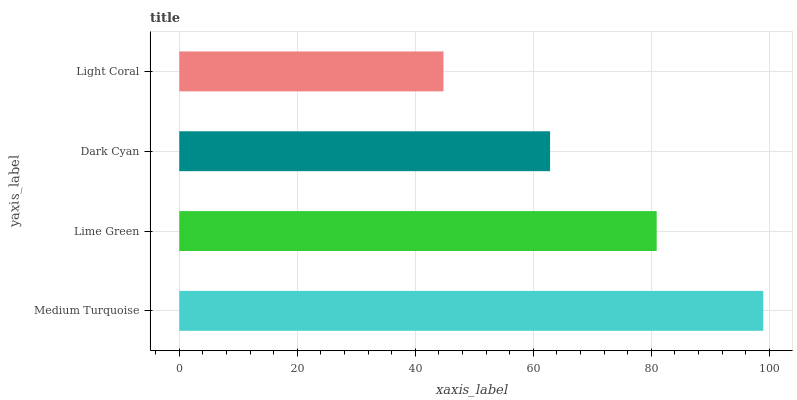Is Light Coral the minimum?
Answer yes or no. Yes. Is Medium Turquoise the maximum?
Answer yes or no. Yes. Is Lime Green the minimum?
Answer yes or no. No. Is Lime Green the maximum?
Answer yes or no. No. Is Medium Turquoise greater than Lime Green?
Answer yes or no. Yes. Is Lime Green less than Medium Turquoise?
Answer yes or no. Yes. Is Lime Green greater than Medium Turquoise?
Answer yes or no. No. Is Medium Turquoise less than Lime Green?
Answer yes or no. No. Is Lime Green the high median?
Answer yes or no. Yes. Is Dark Cyan the low median?
Answer yes or no. Yes. Is Dark Cyan the high median?
Answer yes or no. No. Is Light Coral the low median?
Answer yes or no. No. 